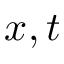Convert formula to latex. <formula><loc_0><loc_0><loc_500><loc_500>x , t</formula> 